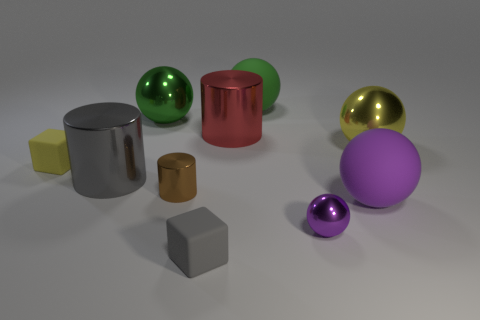What number of other objects are the same shape as the tiny gray matte object?
Offer a very short reply. 1. There is a sphere that is both right of the tiny purple thing and in front of the gray cylinder; what material is it?
Make the answer very short. Rubber. How many objects are big matte things or blue blocks?
Ensure brevity in your answer.  2. Is the number of red shiny cylinders greater than the number of tiny purple shiny cylinders?
Ensure brevity in your answer.  Yes. There is a cylinder behind the cylinder that is left of the brown cylinder; how big is it?
Keep it short and to the point. Large. There is another tiny thing that is the same shape as the tiny yellow rubber object; what color is it?
Your answer should be very brief. Gray. How big is the gray block?
Provide a succinct answer. Small. How many blocks are shiny things or big purple rubber objects?
Provide a succinct answer. 0. There is a purple metallic object that is the same shape as the green matte object; what size is it?
Make the answer very short. Small. How many large purple rubber cylinders are there?
Ensure brevity in your answer.  0. 